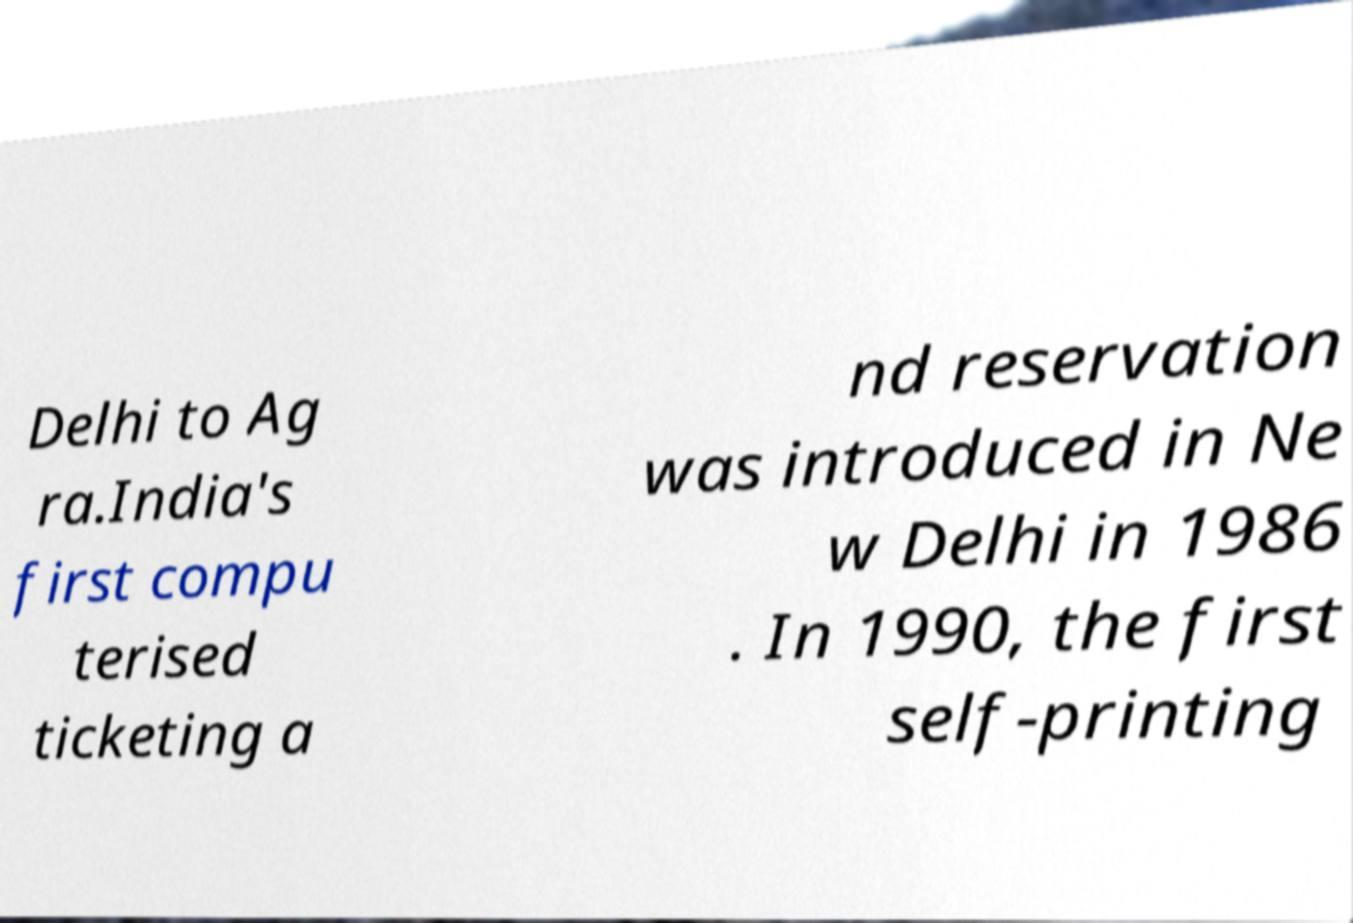I need the written content from this picture converted into text. Can you do that? Delhi to Ag ra.India's first compu terised ticketing a nd reservation was introduced in Ne w Delhi in 1986 . In 1990, the first self-printing 